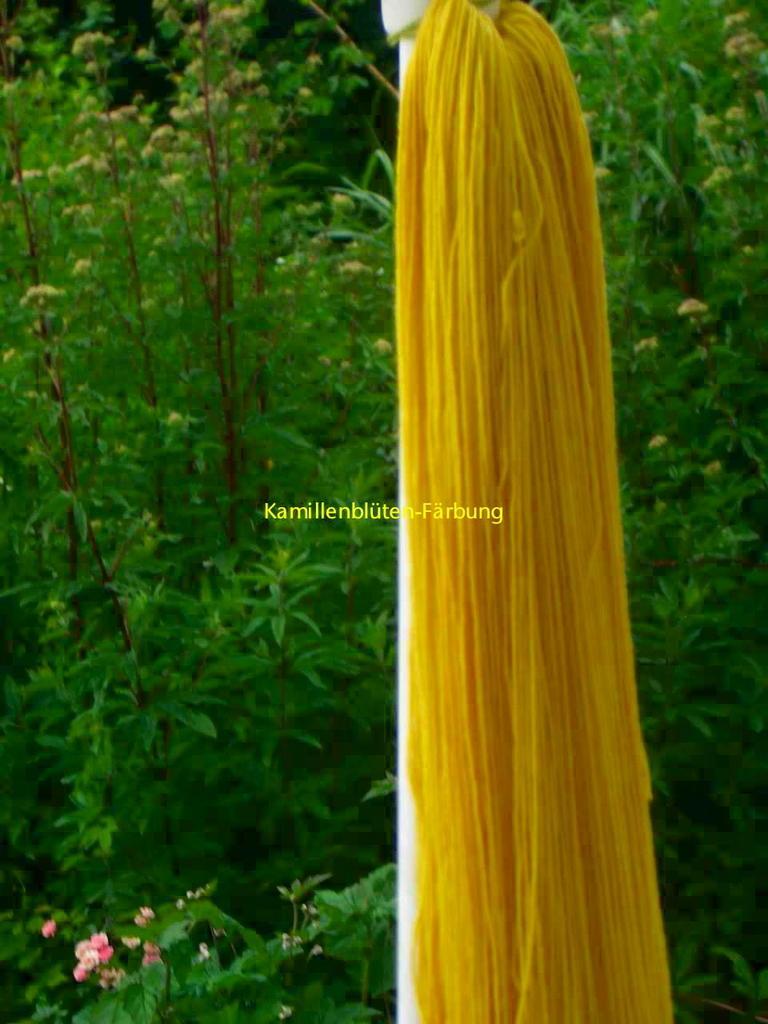Please provide a concise description of this image. In this image we can see fiber to the pole and plants. 